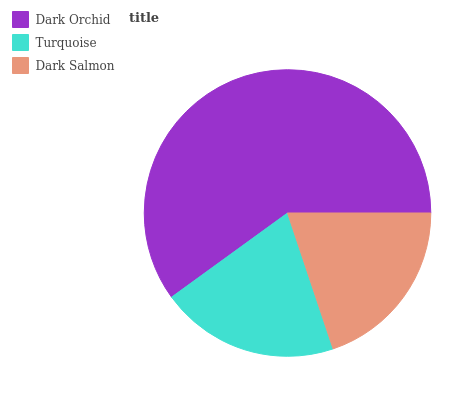Is Dark Salmon the minimum?
Answer yes or no. Yes. Is Dark Orchid the maximum?
Answer yes or no. Yes. Is Turquoise the minimum?
Answer yes or no. No. Is Turquoise the maximum?
Answer yes or no. No. Is Dark Orchid greater than Turquoise?
Answer yes or no. Yes. Is Turquoise less than Dark Orchid?
Answer yes or no. Yes. Is Turquoise greater than Dark Orchid?
Answer yes or no. No. Is Dark Orchid less than Turquoise?
Answer yes or no. No. Is Turquoise the high median?
Answer yes or no. Yes. Is Turquoise the low median?
Answer yes or no. Yes. Is Dark Salmon the high median?
Answer yes or no. No. Is Dark Salmon the low median?
Answer yes or no. No. 